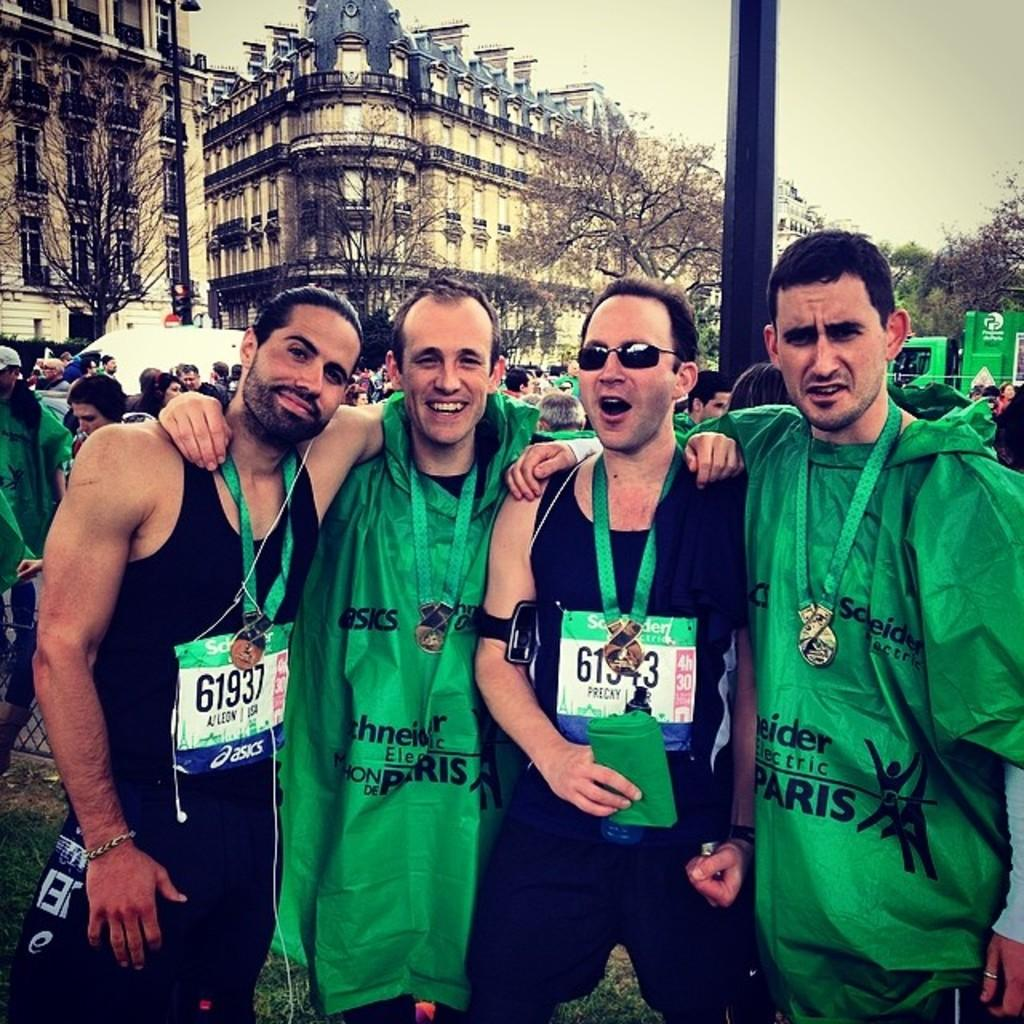How many men are in the foreground of the image? There are four men standing in the foreground of the image. What are the men doing in the image? The men are posing for a camera. What can be seen in the background of the image? There are people, a pole, vehicles, buildings, trees, and the sky visible in the background of the image. What type of tent can be seen in the image? There is no tent present in the image. Are there any sailboats visible in the image? There are no sailboats present in the image. 